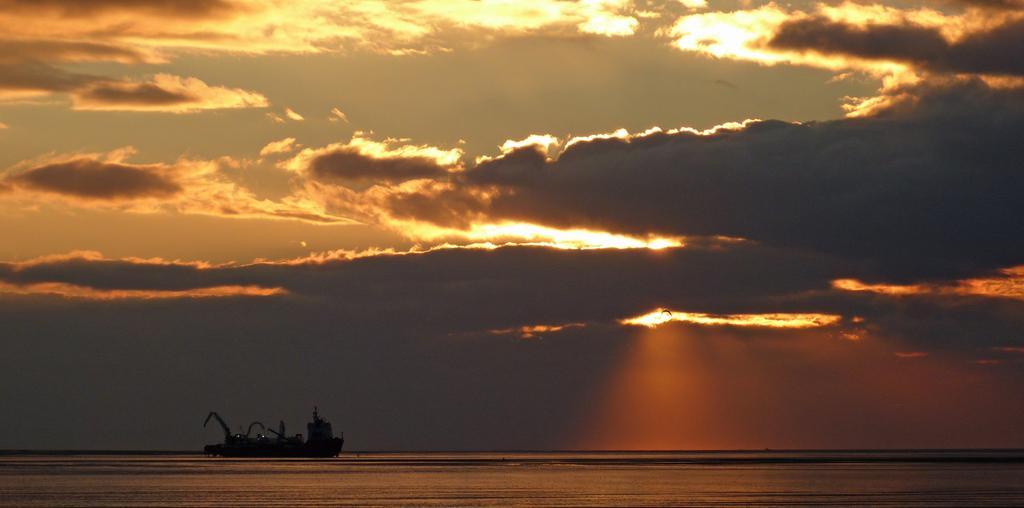Could you give a brief overview of what you see in this image? In the picture we can see water and a ship in it and in the background, we can see a sky with clouds which are black in color and behind the clouds we can see a sunshine. 